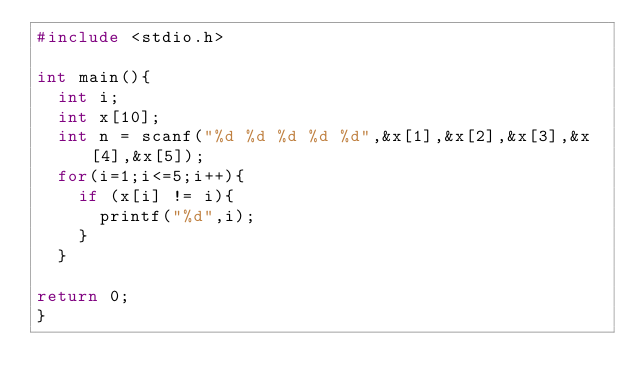<code> <loc_0><loc_0><loc_500><loc_500><_C_>#include <stdio.h>

int main(){
  int i;
  int x[10];
  int n = scanf("%d %d %d %d %d",&x[1],&x[2],&x[3],&x[4],&x[5]);
  for(i=1;i<=5;i++){
    if (x[i] != i){
      printf("%d",i);
    }
  } 
  
return 0;
}</code> 